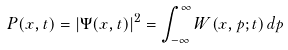<formula> <loc_0><loc_0><loc_500><loc_500>P ( x , t ) = \left | \Psi ( x , t ) \right | ^ { 2 } = \int _ { - \infty } ^ { \infty } { W ( x , p ; t ) \, d p }</formula> 